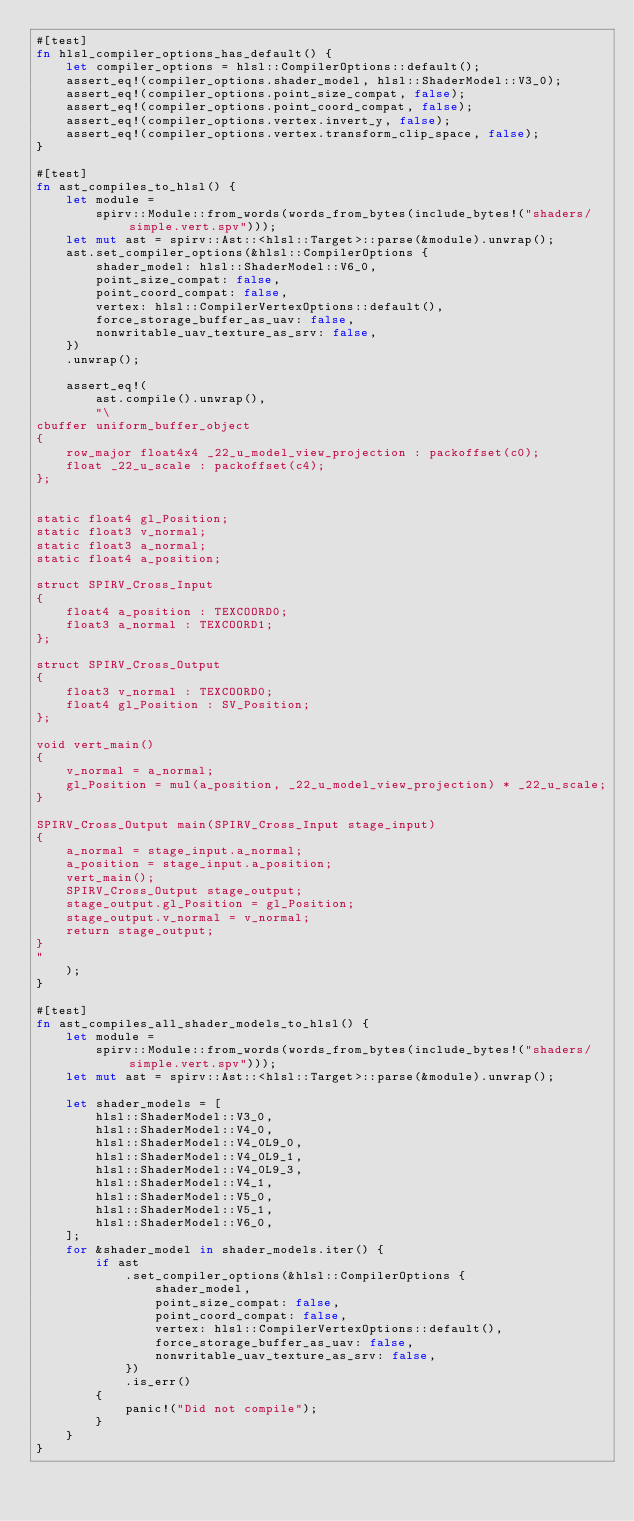<code> <loc_0><loc_0><loc_500><loc_500><_Rust_>#[test]
fn hlsl_compiler_options_has_default() {
    let compiler_options = hlsl::CompilerOptions::default();
    assert_eq!(compiler_options.shader_model, hlsl::ShaderModel::V3_0);
    assert_eq!(compiler_options.point_size_compat, false);
    assert_eq!(compiler_options.point_coord_compat, false);
    assert_eq!(compiler_options.vertex.invert_y, false);
    assert_eq!(compiler_options.vertex.transform_clip_space, false);
}

#[test]
fn ast_compiles_to_hlsl() {
    let module =
        spirv::Module::from_words(words_from_bytes(include_bytes!("shaders/simple.vert.spv")));
    let mut ast = spirv::Ast::<hlsl::Target>::parse(&module).unwrap();
    ast.set_compiler_options(&hlsl::CompilerOptions {
        shader_model: hlsl::ShaderModel::V6_0,
        point_size_compat: false,
        point_coord_compat: false,
        vertex: hlsl::CompilerVertexOptions::default(),
        force_storage_buffer_as_uav: false,
        nonwritable_uav_texture_as_srv: false,
    })
    .unwrap();

    assert_eq!(
        ast.compile().unwrap(),
        "\
cbuffer uniform_buffer_object
{
    row_major float4x4 _22_u_model_view_projection : packoffset(c0);
    float _22_u_scale : packoffset(c4);
};


static float4 gl_Position;
static float3 v_normal;
static float3 a_normal;
static float4 a_position;

struct SPIRV_Cross_Input
{
    float4 a_position : TEXCOORD0;
    float3 a_normal : TEXCOORD1;
};

struct SPIRV_Cross_Output
{
    float3 v_normal : TEXCOORD0;
    float4 gl_Position : SV_Position;
};

void vert_main()
{
    v_normal = a_normal;
    gl_Position = mul(a_position, _22_u_model_view_projection) * _22_u_scale;
}

SPIRV_Cross_Output main(SPIRV_Cross_Input stage_input)
{
    a_normal = stage_input.a_normal;
    a_position = stage_input.a_position;
    vert_main();
    SPIRV_Cross_Output stage_output;
    stage_output.gl_Position = gl_Position;
    stage_output.v_normal = v_normal;
    return stage_output;
}
"
    );
}

#[test]
fn ast_compiles_all_shader_models_to_hlsl() {
    let module =
        spirv::Module::from_words(words_from_bytes(include_bytes!("shaders/simple.vert.spv")));
    let mut ast = spirv::Ast::<hlsl::Target>::parse(&module).unwrap();

    let shader_models = [
        hlsl::ShaderModel::V3_0,
        hlsl::ShaderModel::V4_0,
        hlsl::ShaderModel::V4_0L9_0,
        hlsl::ShaderModel::V4_0L9_1,
        hlsl::ShaderModel::V4_0L9_3,
        hlsl::ShaderModel::V4_1,
        hlsl::ShaderModel::V5_0,
        hlsl::ShaderModel::V5_1,
        hlsl::ShaderModel::V6_0,
    ];
    for &shader_model in shader_models.iter() {
        if ast
            .set_compiler_options(&hlsl::CompilerOptions {
                shader_model,
                point_size_compat: false,
                point_coord_compat: false,
                vertex: hlsl::CompilerVertexOptions::default(),
                force_storage_buffer_as_uav: false,
                nonwritable_uav_texture_as_srv: false,
            })
            .is_err()
        {
            panic!("Did not compile");
        }
    }
}
</code> 